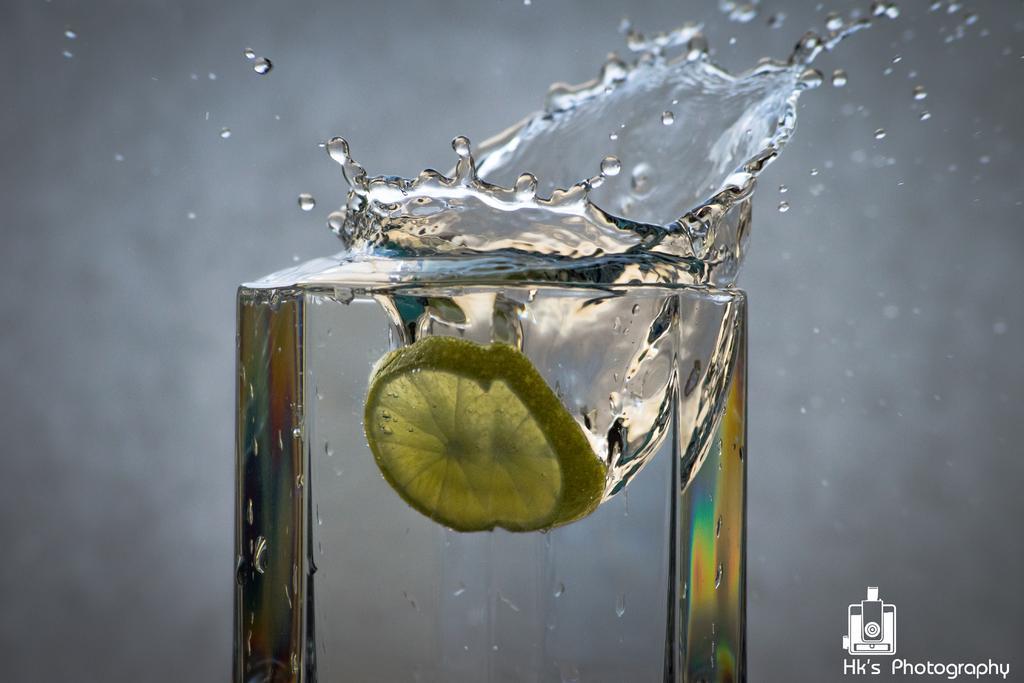How would you summarize this image in a sentence or two? There is a lemon piece in the water. Which is in the glass. There are water drops coming out from the glass. In the right bottom corner, there is watermark. And the background is blurred. 